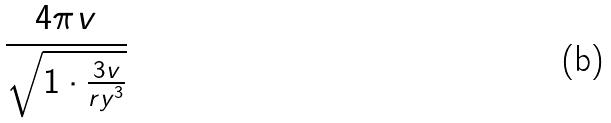<formula> <loc_0><loc_0><loc_500><loc_500>\frac { 4 \pi v } { \sqrt { 1 \cdot \frac { 3 v } { r y ^ { 3 } } } }</formula> 